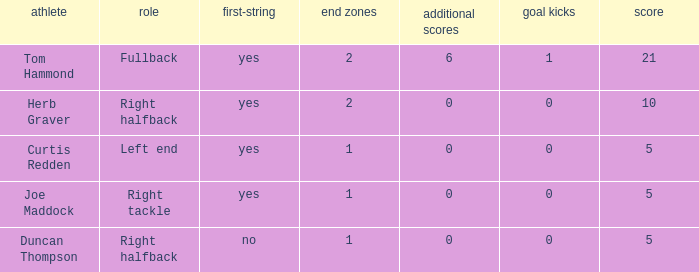Identify the maximum extra points achieved by a right tackle. 0.0. 